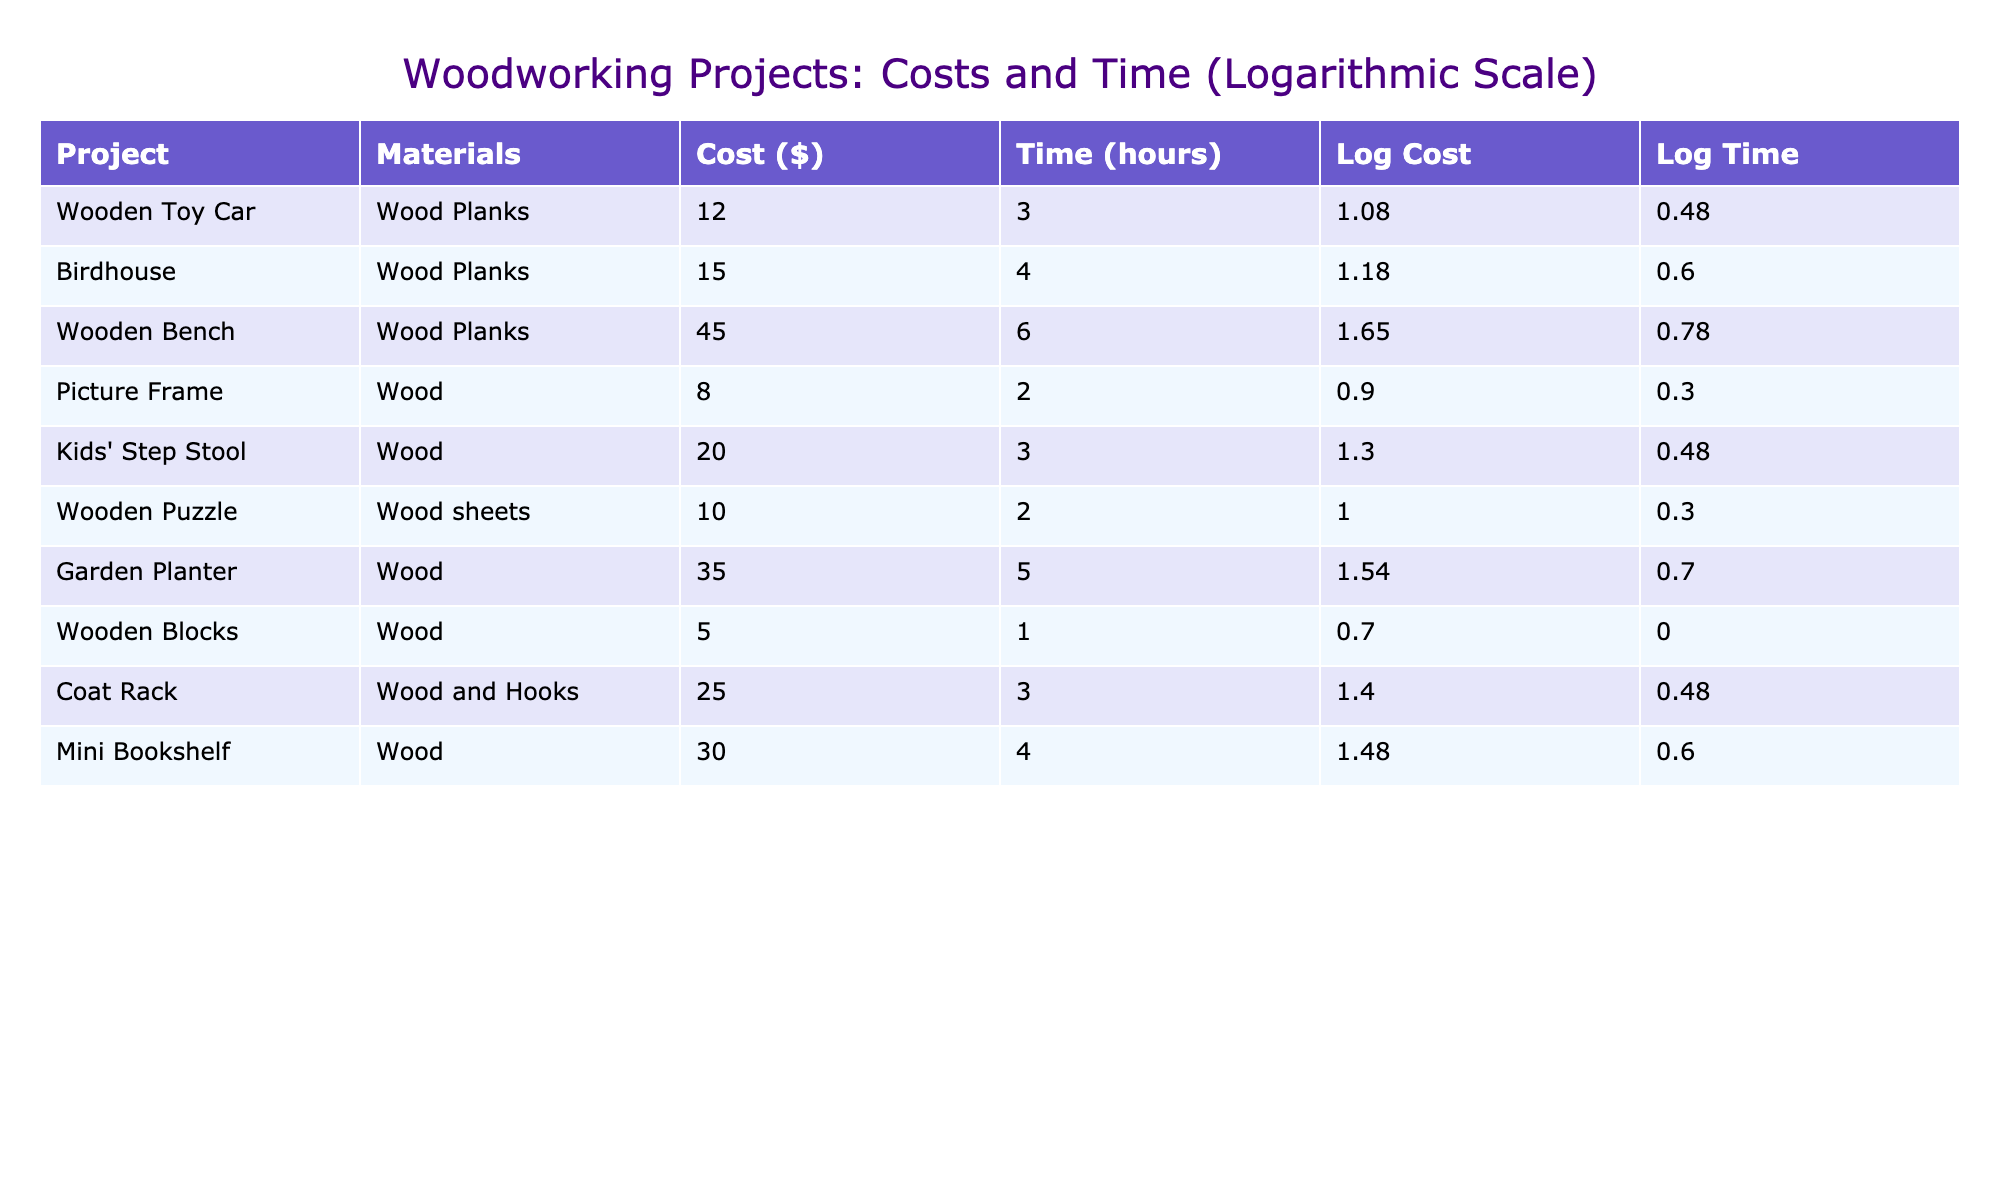What is the cost of the Wooden Bench? The table shows that the cost for the Wooden Bench project is listed in the Cost column. By looking at that row, we find the cost is 45.00.
Answer: 45.00 Which project has the highest cost? We will compare all the costs listed under the Cost column. The Wooden Bench costs 45.00, while the Birdhouse is 15.00, the Garden Planter is 35.00, and the others are less than these. Therefore, the Wooden Bench has the highest cost.
Answer: Wooden Bench What is the total time required for the Kids' Step Stool and Birdhouse projects? We first look at the Time (hours) values for those two projects. The Kids' Step Stool takes 3 hours and the Birdhouse takes 4 hours. Adding these together gives us 3 + 4 = 7 hours.
Answer: 7 hours Is the cost of the Wooden Toy Car less than that of the Wooden Puzzle? We check the Cost of both projects. The Wooden Toy Car costs 12.00, while the Wooden Puzzle costs 10.00. Since 12.00 is greater than 10.00, the answer is no.
Answer: No What is the average cost of all the projects listed? We first sum all the costs: (12 + 15 + 45 + 8 + 20 + 10 + 35 + 5 + 25 + 30) = 210. There are 10 projects, so the average cost is 210 divided by 10, which equals 21.00.
Answer: 21.00 Which material is used the most frequently across projects? By observing the Materials column, we note how many times each material appears. Wood Planks appears in 3 projects, Wood in 5 projects, and Wood and Hooks in 1, while Wood sheets appear in 1 project too. Since Wood appears most frequently, the answer is Wood.
Answer: Wood Which project took the least amount of time, and how many hours did it take? We look at the Time (hours) column to find the smallest value. Wooden Blocks took 1 hour, which is less than all other projects, so the answer is 1 hour for the Wooden Blocks.
Answer: 1 hour What is the difference in time between the Wooden Bench and the Birdhouse projects? The time for the Wooden Bench is 6 hours and for the Birdhouse, it is 4 hours. We take the difference: 6 - 4 = 2 hours, indicating that the Wooden Bench takes 2 hours longer than the Birdhouse.
Answer: 2 hours How many projects have a cost of $20 or more? We check the Cost column and see the projects with costs of 20 or more: Wooden Bench (45.00), Garden Planter (35.00), and Kids' Step Stool (20.00). This totals to 3 projects, so the answer is 3.
Answer: 3 